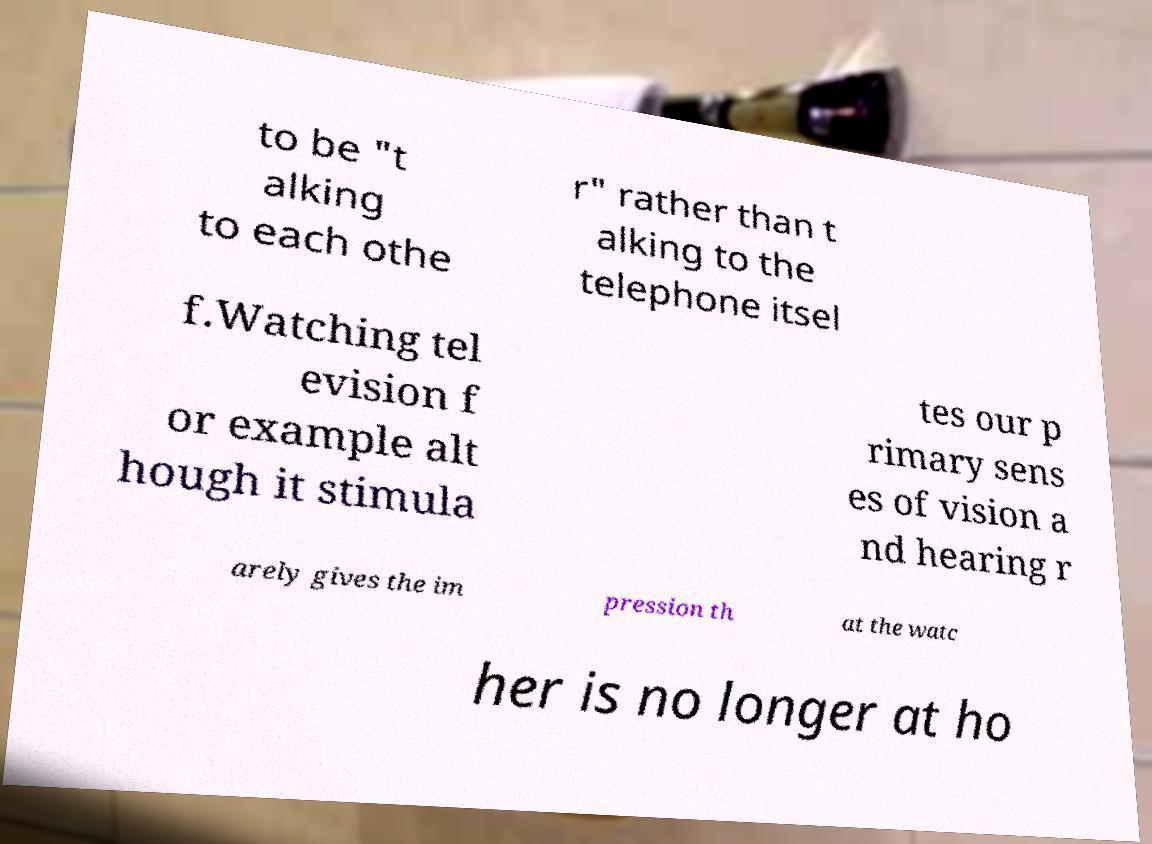Can you accurately transcribe the text from the provided image for me? to be "t alking to each othe r" rather than t alking to the telephone itsel f.Watching tel evision f or example alt hough it stimula tes our p rimary sens es of vision a nd hearing r arely gives the im pression th at the watc her is no longer at ho 